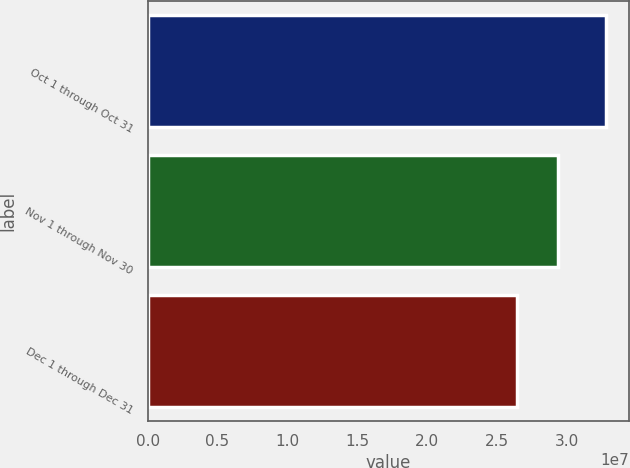Convert chart to OTSL. <chart><loc_0><loc_0><loc_500><loc_500><bar_chart><fcel>Oct 1 through Oct 31<fcel>Nov 1 through Nov 30<fcel>Dec 1 through Dec 31<nl><fcel>3.2831e+07<fcel>2.94288e+07<fcel>2.64281e+07<nl></chart> 